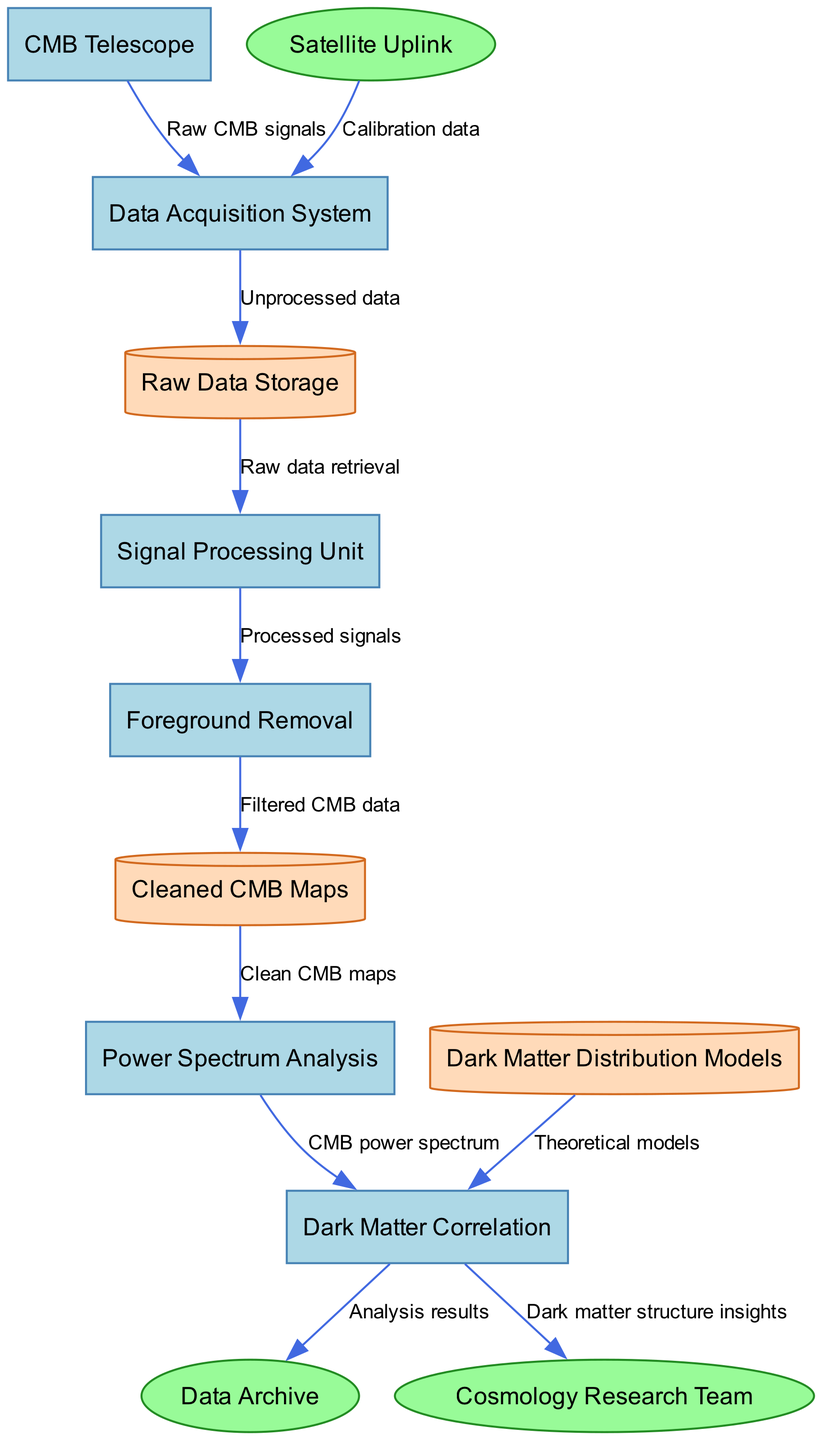What is the first process that receives data? The diagram shows that "CMB Telescope" is the first process in the flow, indicated as the source of "Raw CMB signals" which are directed to the "Data Acquisition System."
Answer: CMB Telescope How many processes are there in the diagram? The diagram lists six processes: "CMB Telescope," "Data Acquisition System," "Signal Processing Unit," "Foreground Removal," "Power Spectrum Analysis," and "Dark Matter Correlation." Counting these processes gives a total of six.
Answer: 6 Which external entity provides calibration data? The diagram shows that "Satellite Uplink" is an external entity, and it connects to the "Data Acquisition System" with the label "Calibration data."
Answer: Satellite Uplink What is the final output of the "Dark Matter Correlation" process? The output of the "Dark Matter Correlation" process is directed to the "Cosmology Research Team," labeled as "Dark matter structure insights."
Answer: Dark matter structure insights Which process follows "Foreground Removal"? According to the diagram, "Foreground Removal" is followed by the process "Cleaned CMB Maps," as indicated by the flow of "Filtered CMB data."
Answer: Cleaned CMB Maps What type of data is stored in "Raw Data Storage"? The data flow from the "Data Acquisition System" to "Raw Data Storage" is labeled "Unprocessed data," indicating that this storage holds unprocessed information collected by the system.
Answer: Unprocessed data How many data stores are there in the diagram? The diagram identifies three data stores: "Raw Data Storage," "Cleaned CMB Maps," and "Dark Matter Distribution Models." Therefore, counting these gives us a total of three data stores.
Answer: 3 What data flows from "Cleaned CMB Maps" to "Power Spectrum Analysis"? The flow of data labeled as "Clean CMB maps" is directed from "Cleaned CMB Maps" to "Power Spectrum Analysis." This indicates that this specific data type is what is being passed along.
Answer: Clean CMB maps What connects "Dark Matter Distribution Models" to "Dark Matter Correlation"? In the diagram, the connection from "Dark Matter Distribution Models" to "Dark Matter Correlation" is labeled "Theoretical models," indicating the basis for correlation analysis.
Answer: Theoretical models 